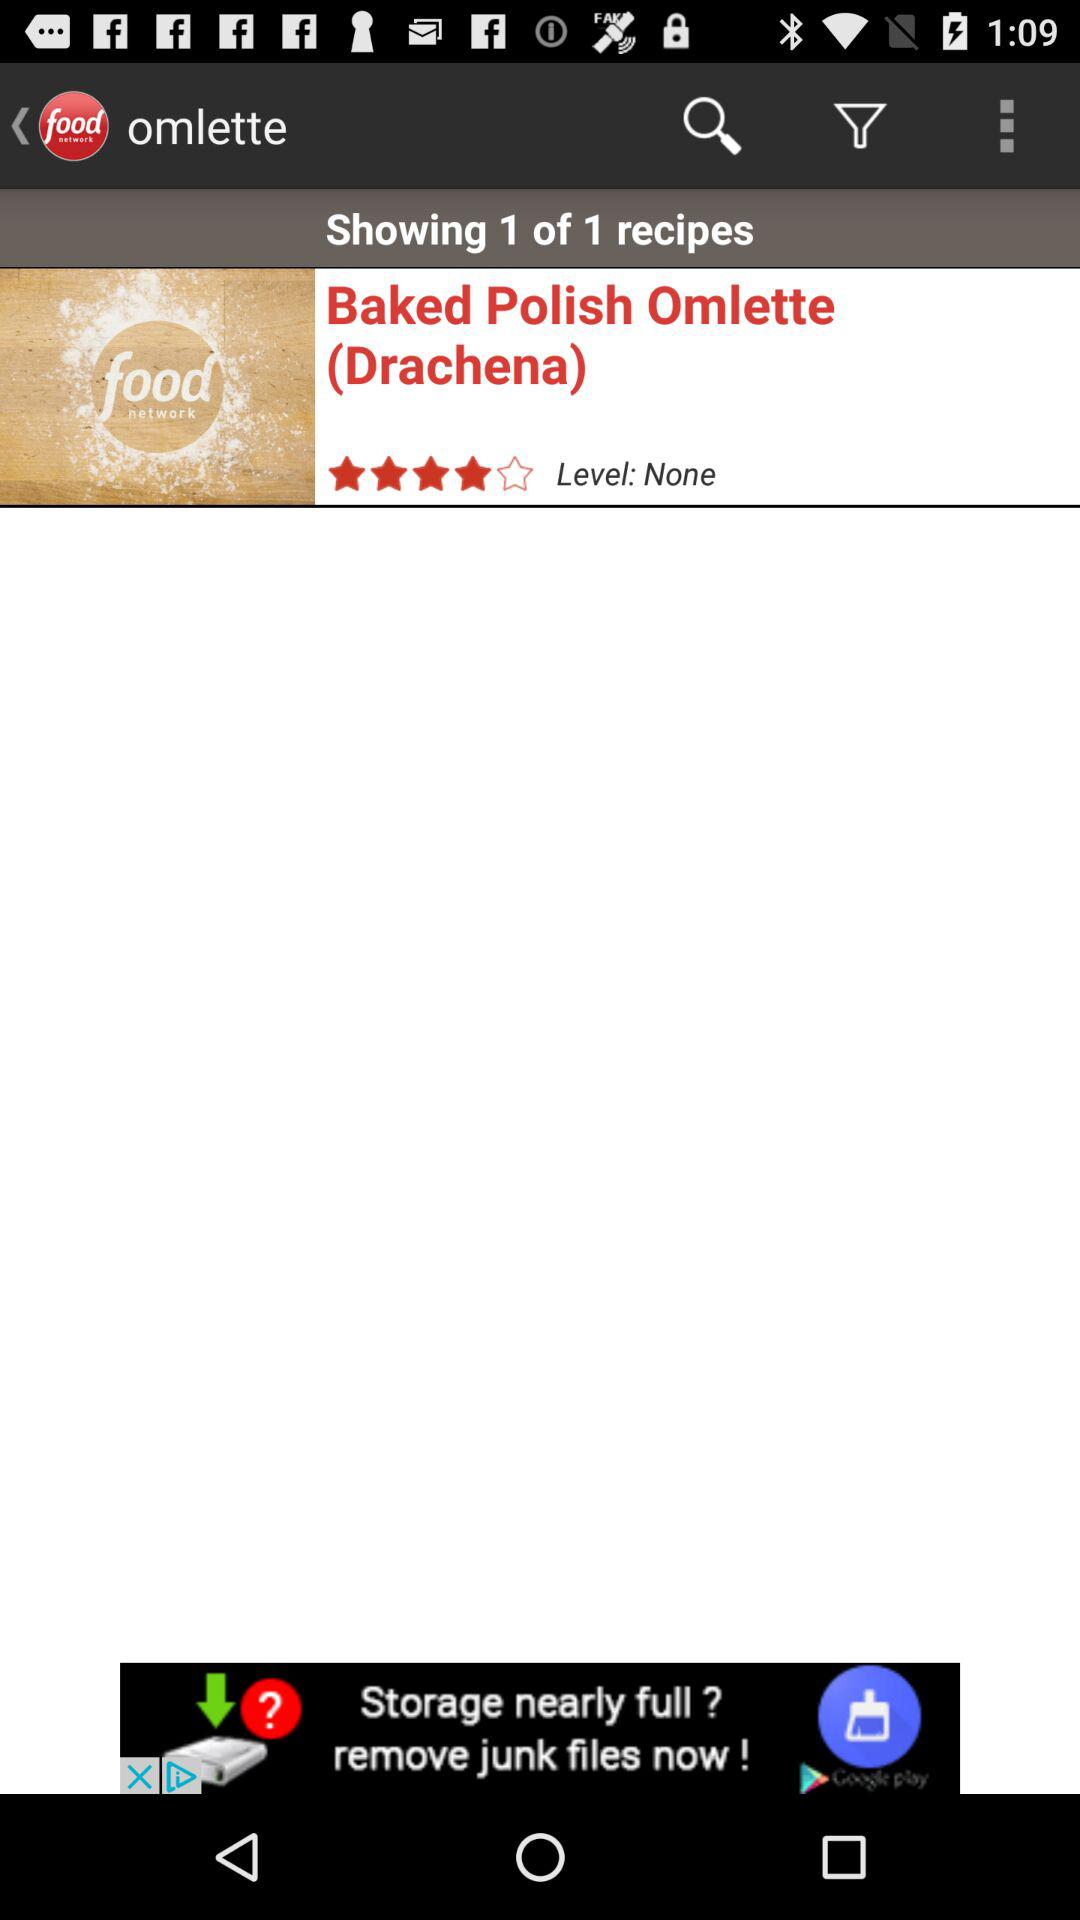What is the name of the application? The name of the application is "food network". 